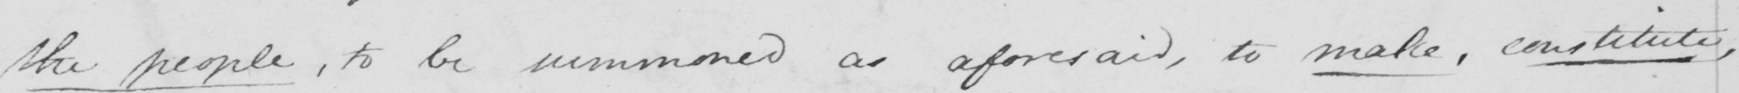Please provide the text content of this handwritten line. the people , to be summoned as aforesaid , to make , constitute 